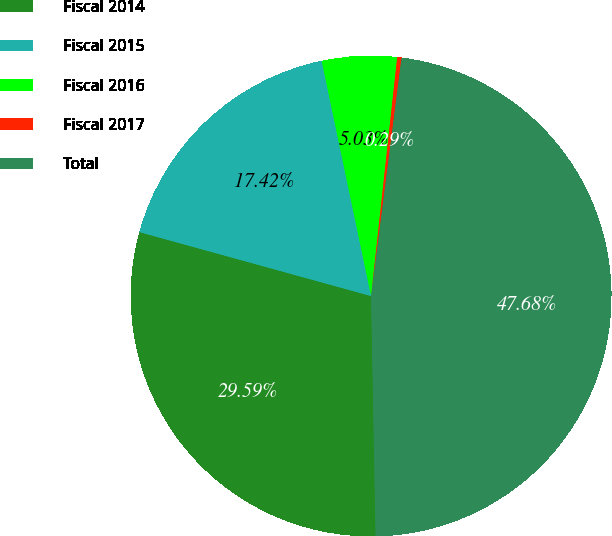<chart> <loc_0><loc_0><loc_500><loc_500><pie_chart><fcel>Fiscal 2014<fcel>Fiscal 2015<fcel>Fiscal 2016<fcel>Fiscal 2017<fcel>Total<nl><fcel>29.59%<fcel>17.42%<fcel>5.03%<fcel>0.29%<fcel>47.68%<nl></chart> 